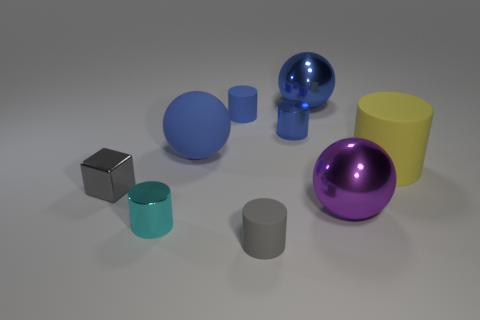How many blue balls must be subtracted to get 1 blue balls? 1 Subtract all yellow cylinders. How many cylinders are left? 4 Subtract 2 cylinders. How many cylinders are left? 3 Subtract all big cylinders. How many cylinders are left? 4 Subtract all green cylinders. Subtract all green balls. How many cylinders are left? 5 Add 1 gray rubber cylinders. How many objects exist? 10 Subtract all blocks. How many objects are left? 8 Subtract 0 brown cylinders. How many objects are left? 9 Subtract all cyan objects. Subtract all large blue matte balls. How many objects are left? 7 Add 6 large yellow rubber things. How many large yellow rubber things are left? 7 